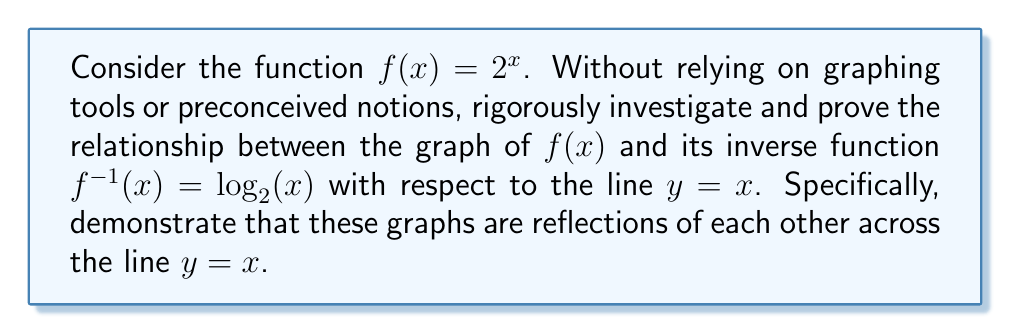Teach me how to tackle this problem. To rigorously prove this relationship, we'll follow these steps:

1) First, let's recall that for any point $(a, b)$ on the graph of $f(x)$, the corresponding point on the graph of $f^{-1}(x)$ is $(b, a)$.

2) Now, let's consider an arbitrary point $(x, y)$ on the graph of $f(x)$. This means:

   $y = f(x) = 2^x$

3) The corresponding point on the graph of $f^{-1}(x)$ would be $(y, x)$. Let's verify that this point satisfies the equation of $f^{-1}(x)$:

   $x = f^{-1}(y) = \log_2(y)$

   This is true because $y = 2^x$ implies $x = \log_2(y)$.

4) Now, let's consider the line $y = x$. A point $(a, a)$ on this line is equidistant from $(x, y)$ and $(y, x)$ if and only if:

   $$(a-x)^2 + (a-y)^2 = (a-y)^2 + (a-x)^2$$

   This equation is always true, regardless of the values of $x$, $y$, and $a$.

5) To find the point $(a, a)$ that's exactly halfway between $(x, y)$ and $(y, x)$, we can use the midpoint formula:

   $$a = \frac{x + y}{2}$$

6) This means that for any point $(x, y)$ on $f(x)$, we can find a corresponding point $(y, x)$ on $f^{-1}(x)$, and these points are equidistant from the line $y = x$.

7) The line connecting $(x, y)$ and $(y, x)$ is perpendicular to $y = x$. We can prove this by showing that the product of their slopes is -1:

   Slope of line connecting $(x, y)$ and $(y, x)$: $\frac{x-y}{y-x} = -1$
   Slope of $y = x$: 1

   $-1 \cdot 1 = -1$

8) Since every point on $f(x)$ has a corresponding point on $f^{-1}(x)$ that is equidistant from $y = x$ and connected by a line perpendicular to $y = x$, we have proved that the graphs of $f(x)$ and $f^{-1}(x)$ are reflections of each other across the line $y = x$.
Answer: The graphs of $f(x) = 2^x$ and its inverse function $f^{-1}(x) = \log_2(x)$ are reflections of each other across the line $y = x$. 